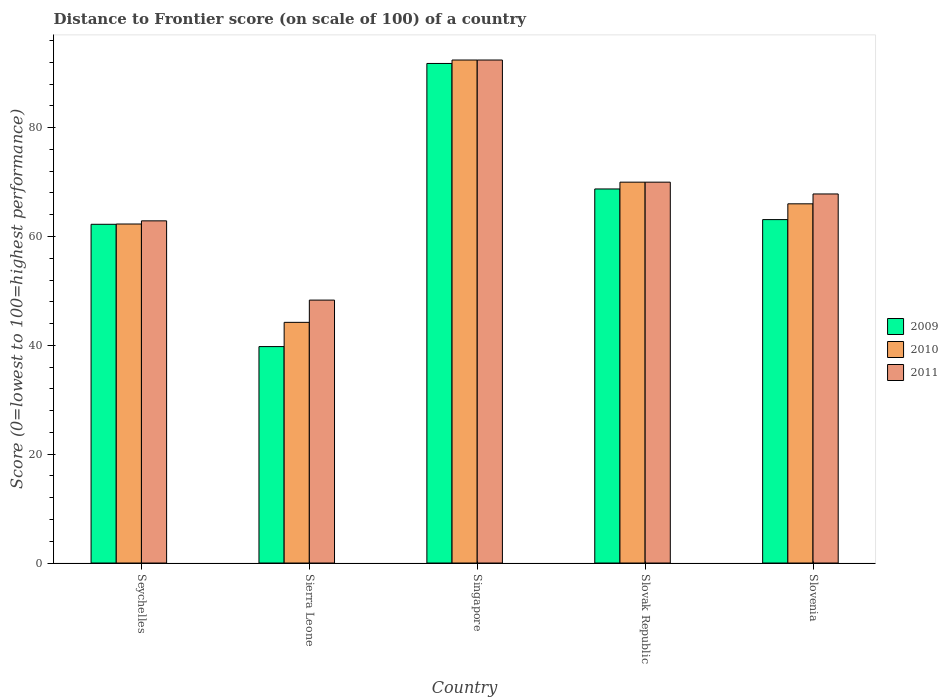How many different coloured bars are there?
Provide a succinct answer. 3. Are the number of bars on each tick of the X-axis equal?
Make the answer very short. Yes. How many bars are there on the 2nd tick from the left?
Ensure brevity in your answer.  3. How many bars are there on the 1st tick from the right?
Give a very brief answer. 3. What is the label of the 1st group of bars from the left?
Ensure brevity in your answer.  Seychelles. In how many cases, is the number of bars for a given country not equal to the number of legend labels?
Provide a succinct answer. 0. What is the distance to frontier score of in 2011 in Slovenia?
Keep it short and to the point. 67.81. Across all countries, what is the maximum distance to frontier score of in 2011?
Provide a succinct answer. 92.42. Across all countries, what is the minimum distance to frontier score of in 2011?
Make the answer very short. 48.31. In which country was the distance to frontier score of in 2009 maximum?
Offer a terse response. Singapore. In which country was the distance to frontier score of in 2009 minimum?
Give a very brief answer. Sierra Leone. What is the total distance to frontier score of in 2011 in the graph?
Provide a succinct answer. 341.39. What is the difference between the distance to frontier score of in 2009 in Sierra Leone and that in Slovenia?
Provide a short and direct response. -23.33. What is the difference between the distance to frontier score of in 2010 in Singapore and the distance to frontier score of in 2011 in Seychelles?
Make the answer very short. 29.55. What is the average distance to frontier score of in 2009 per country?
Your answer should be compact. 65.13. What is the difference between the distance to frontier score of of/in 2009 and distance to frontier score of of/in 2011 in Slovenia?
Your answer should be very brief. -4.71. In how many countries, is the distance to frontier score of in 2010 greater than 8?
Offer a very short reply. 5. What is the ratio of the distance to frontier score of in 2010 in Sierra Leone to that in Slovenia?
Your answer should be very brief. 0.67. Is the distance to frontier score of in 2009 in Singapore less than that in Slovenia?
Offer a terse response. No. What is the difference between the highest and the second highest distance to frontier score of in 2011?
Your response must be concise. -24.61. What is the difference between the highest and the lowest distance to frontier score of in 2011?
Give a very brief answer. 44.11. In how many countries, is the distance to frontier score of in 2009 greater than the average distance to frontier score of in 2009 taken over all countries?
Ensure brevity in your answer.  2. What does the 1st bar from the right in Sierra Leone represents?
Provide a succinct answer. 2011. Are all the bars in the graph horizontal?
Your answer should be compact. No. How many countries are there in the graph?
Ensure brevity in your answer.  5. Are the values on the major ticks of Y-axis written in scientific E-notation?
Your response must be concise. No. Does the graph contain any zero values?
Give a very brief answer. No. Where does the legend appear in the graph?
Your answer should be compact. Center right. What is the title of the graph?
Keep it short and to the point. Distance to Frontier score (on scale of 100) of a country. What is the label or title of the X-axis?
Offer a very short reply. Country. What is the label or title of the Y-axis?
Provide a short and direct response. Score (0=lowest to 100=highest performance). What is the Score (0=lowest to 100=highest performance) in 2009 in Seychelles?
Offer a terse response. 62.24. What is the Score (0=lowest to 100=highest performance) of 2010 in Seychelles?
Your response must be concise. 62.29. What is the Score (0=lowest to 100=highest performance) of 2011 in Seychelles?
Your answer should be compact. 62.87. What is the Score (0=lowest to 100=highest performance) in 2009 in Sierra Leone?
Offer a terse response. 39.77. What is the Score (0=lowest to 100=highest performance) of 2010 in Sierra Leone?
Ensure brevity in your answer.  44.22. What is the Score (0=lowest to 100=highest performance) of 2011 in Sierra Leone?
Your response must be concise. 48.31. What is the Score (0=lowest to 100=highest performance) in 2009 in Singapore?
Offer a terse response. 91.79. What is the Score (0=lowest to 100=highest performance) in 2010 in Singapore?
Offer a very short reply. 92.42. What is the Score (0=lowest to 100=highest performance) in 2011 in Singapore?
Offer a very short reply. 92.42. What is the Score (0=lowest to 100=highest performance) of 2009 in Slovak Republic?
Your answer should be very brief. 68.73. What is the Score (0=lowest to 100=highest performance) in 2010 in Slovak Republic?
Provide a short and direct response. 69.98. What is the Score (0=lowest to 100=highest performance) in 2011 in Slovak Republic?
Your answer should be compact. 69.98. What is the Score (0=lowest to 100=highest performance) in 2009 in Slovenia?
Give a very brief answer. 63.1. What is the Score (0=lowest to 100=highest performance) in 2010 in Slovenia?
Provide a short and direct response. 66. What is the Score (0=lowest to 100=highest performance) of 2011 in Slovenia?
Your response must be concise. 67.81. Across all countries, what is the maximum Score (0=lowest to 100=highest performance) in 2009?
Offer a very short reply. 91.79. Across all countries, what is the maximum Score (0=lowest to 100=highest performance) of 2010?
Provide a short and direct response. 92.42. Across all countries, what is the maximum Score (0=lowest to 100=highest performance) of 2011?
Keep it short and to the point. 92.42. Across all countries, what is the minimum Score (0=lowest to 100=highest performance) in 2009?
Your answer should be compact. 39.77. Across all countries, what is the minimum Score (0=lowest to 100=highest performance) of 2010?
Offer a very short reply. 44.22. Across all countries, what is the minimum Score (0=lowest to 100=highest performance) in 2011?
Your answer should be compact. 48.31. What is the total Score (0=lowest to 100=highest performance) in 2009 in the graph?
Your response must be concise. 325.63. What is the total Score (0=lowest to 100=highest performance) of 2010 in the graph?
Give a very brief answer. 334.91. What is the total Score (0=lowest to 100=highest performance) of 2011 in the graph?
Keep it short and to the point. 341.39. What is the difference between the Score (0=lowest to 100=highest performance) in 2009 in Seychelles and that in Sierra Leone?
Your answer should be very brief. 22.47. What is the difference between the Score (0=lowest to 100=highest performance) of 2010 in Seychelles and that in Sierra Leone?
Provide a succinct answer. 18.07. What is the difference between the Score (0=lowest to 100=highest performance) of 2011 in Seychelles and that in Sierra Leone?
Ensure brevity in your answer.  14.56. What is the difference between the Score (0=lowest to 100=highest performance) of 2009 in Seychelles and that in Singapore?
Keep it short and to the point. -29.55. What is the difference between the Score (0=lowest to 100=highest performance) in 2010 in Seychelles and that in Singapore?
Your answer should be compact. -30.13. What is the difference between the Score (0=lowest to 100=highest performance) in 2011 in Seychelles and that in Singapore?
Your answer should be compact. -29.55. What is the difference between the Score (0=lowest to 100=highest performance) of 2009 in Seychelles and that in Slovak Republic?
Offer a very short reply. -6.49. What is the difference between the Score (0=lowest to 100=highest performance) of 2010 in Seychelles and that in Slovak Republic?
Offer a terse response. -7.69. What is the difference between the Score (0=lowest to 100=highest performance) of 2011 in Seychelles and that in Slovak Republic?
Give a very brief answer. -7.11. What is the difference between the Score (0=lowest to 100=highest performance) in 2009 in Seychelles and that in Slovenia?
Your answer should be compact. -0.86. What is the difference between the Score (0=lowest to 100=highest performance) in 2010 in Seychelles and that in Slovenia?
Give a very brief answer. -3.71. What is the difference between the Score (0=lowest to 100=highest performance) of 2011 in Seychelles and that in Slovenia?
Provide a succinct answer. -4.94. What is the difference between the Score (0=lowest to 100=highest performance) in 2009 in Sierra Leone and that in Singapore?
Offer a terse response. -52.02. What is the difference between the Score (0=lowest to 100=highest performance) of 2010 in Sierra Leone and that in Singapore?
Offer a terse response. -48.2. What is the difference between the Score (0=lowest to 100=highest performance) in 2011 in Sierra Leone and that in Singapore?
Offer a very short reply. -44.11. What is the difference between the Score (0=lowest to 100=highest performance) of 2009 in Sierra Leone and that in Slovak Republic?
Your response must be concise. -28.96. What is the difference between the Score (0=lowest to 100=highest performance) of 2010 in Sierra Leone and that in Slovak Republic?
Provide a succinct answer. -25.76. What is the difference between the Score (0=lowest to 100=highest performance) of 2011 in Sierra Leone and that in Slovak Republic?
Give a very brief answer. -21.67. What is the difference between the Score (0=lowest to 100=highest performance) in 2009 in Sierra Leone and that in Slovenia?
Provide a succinct answer. -23.33. What is the difference between the Score (0=lowest to 100=highest performance) of 2010 in Sierra Leone and that in Slovenia?
Offer a terse response. -21.78. What is the difference between the Score (0=lowest to 100=highest performance) of 2011 in Sierra Leone and that in Slovenia?
Make the answer very short. -19.5. What is the difference between the Score (0=lowest to 100=highest performance) of 2009 in Singapore and that in Slovak Republic?
Provide a succinct answer. 23.06. What is the difference between the Score (0=lowest to 100=highest performance) in 2010 in Singapore and that in Slovak Republic?
Provide a short and direct response. 22.44. What is the difference between the Score (0=lowest to 100=highest performance) in 2011 in Singapore and that in Slovak Republic?
Your answer should be very brief. 22.44. What is the difference between the Score (0=lowest to 100=highest performance) of 2009 in Singapore and that in Slovenia?
Make the answer very short. 28.69. What is the difference between the Score (0=lowest to 100=highest performance) of 2010 in Singapore and that in Slovenia?
Your answer should be very brief. 26.42. What is the difference between the Score (0=lowest to 100=highest performance) of 2011 in Singapore and that in Slovenia?
Keep it short and to the point. 24.61. What is the difference between the Score (0=lowest to 100=highest performance) in 2009 in Slovak Republic and that in Slovenia?
Your answer should be very brief. 5.63. What is the difference between the Score (0=lowest to 100=highest performance) of 2010 in Slovak Republic and that in Slovenia?
Your response must be concise. 3.98. What is the difference between the Score (0=lowest to 100=highest performance) in 2011 in Slovak Republic and that in Slovenia?
Give a very brief answer. 2.17. What is the difference between the Score (0=lowest to 100=highest performance) of 2009 in Seychelles and the Score (0=lowest to 100=highest performance) of 2010 in Sierra Leone?
Offer a very short reply. 18.02. What is the difference between the Score (0=lowest to 100=highest performance) of 2009 in Seychelles and the Score (0=lowest to 100=highest performance) of 2011 in Sierra Leone?
Provide a short and direct response. 13.93. What is the difference between the Score (0=lowest to 100=highest performance) of 2010 in Seychelles and the Score (0=lowest to 100=highest performance) of 2011 in Sierra Leone?
Ensure brevity in your answer.  13.98. What is the difference between the Score (0=lowest to 100=highest performance) in 2009 in Seychelles and the Score (0=lowest to 100=highest performance) in 2010 in Singapore?
Offer a terse response. -30.18. What is the difference between the Score (0=lowest to 100=highest performance) in 2009 in Seychelles and the Score (0=lowest to 100=highest performance) in 2011 in Singapore?
Your answer should be very brief. -30.18. What is the difference between the Score (0=lowest to 100=highest performance) of 2010 in Seychelles and the Score (0=lowest to 100=highest performance) of 2011 in Singapore?
Give a very brief answer. -30.13. What is the difference between the Score (0=lowest to 100=highest performance) in 2009 in Seychelles and the Score (0=lowest to 100=highest performance) in 2010 in Slovak Republic?
Your response must be concise. -7.74. What is the difference between the Score (0=lowest to 100=highest performance) of 2009 in Seychelles and the Score (0=lowest to 100=highest performance) of 2011 in Slovak Republic?
Your response must be concise. -7.74. What is the difference between the Score (0=lowest to 100=highest performance) of 2010 in Seychelles and the Score (0=lowest to 100=highest performance) of 2011 in Slovak Republic?
Give a very brief answer. -7.69. What is the difference between the Score (0=lowest to 100=highest performance) in 2009 in Seychelles and the Score (0=lowest to 100=highest performance) in 2010 in Slovenia?
Keep it short and to the point. -3.76. What is the difference between the Score (0=lowest to 100=highest performance) of 2009 in Seychelles and the Score (0=lowest to 100=highest performance) of 2011 in Slovenia?
Offer a very short reply. -5.57. What is the difference between the Score (0=lowest to 100=highest performance) in 2010 in Seychelles and the Score (0=lowest to 100=highest performance) in 2011 in Slovenia?
Provide a succinct answer. -5.52. What is the difference between the Score (0=lowest to 100=highest performance) in 2009 in Sierra Leone and the Score (0=lowest to 100=highest performance) in 2010 in Singapore?
Provide a succinct answer. -52.65. What is the difference between the Score (0=lowest to 100=highest performance) in 2009 in Sierra Leone and the Score (0=lowest to 100=highest performance) in 2011 in Singapore?
Your answer should be compact. -52.65. What is the difference between the Score (0=lowest to 100=highest performance) in 2010 in Sierra Leone and the Score (0=lowest to 100=highest performance) in 2011 in Singapore?
Offer a very short reply. -48.2. What is the difference between the Score (0=lowest to 100=highest performance) in 2009 in Sierra Leone and the Score (0=lowest to 100=highest performance) in 2010 in Slovak Republic?
Your answer should be very brief. -30.21. What is the difference between the Score (0=lowest to 100=highest performance) in 2009 in Sierra Leone and the Score (0=lowest to 100=highest performance) in 2011 in Slovak Republic?
Keep it short and to the point. -30.21. What is the difference between the Score (0=lowest to 100=highest performance) in 2010 in Sierra Leone and the Score (0=lowest to 100=highest performance) in 2011 in Slovak Republic?
Offer a terse response. -25.76. What is the difference between the Score (0=lowest to 100=highest performance) of 2009 in Sierra Leone and the Score (0=lowest to 100=highest performance) of 2010 in Slovenia?
Make the answer very short. -26.23. What is the difference between the Score (0=lowest to 100=highest performance) of 2009 in Sierra Leone and the Score (0=lowest to 100=highest performance) of 2011 in Slovenia?
Keep it short and to the point. -28.04. What is the difference between the Score (0=lowest to 100=highest performance) in 2010 in Sierra Leone and the Score (0=lowest to 100=highest performance) in 2011 in Slovenia?
Ensure brevity in your answer.  -23.59. What is the difference between the Score (0=lowest to 100=highest performance) of 2009 in Singapore and the Score (0=lowest to 100=highest performance) of 2010 in Slovak Republic?
Keep it short and to the point. 21.81. What is the difference between the Score (0=lowest to 100=highest performance) of 2009 in Singapore and the Score (0=lowest to 100=highest performance) of 2011 in Slovak Republic?
Ensure brevity in your answer.  21.81. What is the difference between the Score (0=lowest to 100=highest performance) in 2010 in Singapore and the Score (0=lowest to 100=highest performance) in 2011 in Slovak Republic?
Give a very brief answer. 22.44. What is the difference between the Score (0=lowest to 100=highest performance) of 2009 in Singapore and the Score (0=lowest to 100=highest performance) of 2010 in Slovenia?
Provide a short and direct response. 25.79. What is the difference between the Score (0=lowest to 100=highest performance) in 2009 in Singapore and the Score (0=lowest to 100=highest performance) in 2011 in Slovenia?
Make the answer very short. 23.98. What is the difference between the Score (0=lowest to 100=highest performance) in 2010 in Singapore and the Score (0=lowest to 100=highest performance) in 2011 in Slovenia?
Offer a very short reply. 24.61. What is the difference between the Score (0=lowest to 100=highest performance) in 2009 in Slovak Republic and the Score (0=lowest to 100=highest performance) in 2010 in Slovenia?
Provide a short and direct response. 2.73. What is the difference between the Score (0=lowest to 100=highest performance) in 2010 in Slovak Republic and the Score (0=lowest to 100=highest performance) in 2011 in Slovenia?
Offer a very short reply. 2.17. What is the average Score (0=lowest to 100=highest performance) in 2009 per country?
Provide a succinct answer. 65.13. What is the average Score (0=lowest to 100=highest performance) in 2010 per country?
Make the answer very short. 66.98. What is the average Score (0=lowest to 100=highest performance) in 2011 per country?
Offer a terse response. 68.28. What is the difference between the Score (0=lowest to 100=highest performance) in 2009 and Score (0=lowest to 100=highest performance) in 2010 in Seychelles?
Give a very brief answer. -0.05. What is the difference between the Score (0=lowest to 100=highest performance) of 2009 and Score (0=lowest to 100=highest performance) of 2011 in Seychelles?
Provide a short and direct response. -0.63. What is the difference between the Score (0=lowest to 100=highest performance) of 2010 and Score (0=lowest to 100=highest performance) of 2011 in Seychelles?
Make the answer very short. -0.58. What is the difference between the Score (0=lowest to 100=highest performance) in 2009 and Score (0=lowest to 100=highest performance) in 2010 in Sierra Leone?
Ensure brevity in your answer.  -4.45. What is the difference between the Score (0=lowest to 100=highest performance) in 2009 and Score (0=lowest to 100=highest performance) in 2011 in Sierra Leone?
Offer a very short reply. -8.54. What is the difference between the Score (0=lowest to 100=highest performance) of 2010 and Score (0=lowest to 100=highest performance) of 2011 in Sierra Leone?
Your answer should be very brief. -4.09. What is the difference between the Score (0=lowest to 100=highest performance) in 2009 and Score (0=lowest to 100=highest performance) in 2010 in Singapore?
Your answer should be compact. -0.63. What is the difference between the Score (0=lowest to 100=highest performance) of 2009 and Score (0=lowest to 100=highest performance) of 2011 in Singapore?
Your answer should be compact. -0.63. What is the difference between the Score (0=lowest to 100=highest performance) of 2010 and Score (0=lowest to 100=highest performance) of 2011 in Singapore?
Give a very brief answer. 0. What is the difference between the Score (0=lowest to 100=highest performance) in 2009 and Score (0=lowest to 100=highest performance) in 2010 in Slovak Republic?
Provide a short and direct response. -1.25. What is the difference between the Score (0=lowest to 100=highest performance) in 2009 and Score (0=lowest to 100=highest performance) in 2011 in Slovak Republic?
Your answer should be compact. -1.25. What is the difference between the Score (0=lowest to 100=highest performance) in 2009 and Score (0=lowest to 100=highest performance) in 2011 in Slovenia?
Your answer should be compact. -4.71. What is the difference between the Score (0=lowest to 100=highest performance) in 2010 and Score (0=lowest to 100=highest performance) in 2011 in Slovenia?
Your answer should be compact. -1.81. What is the ratio of the Score (0=lowest to 100=highest performance) of 2009 in Seychelles to that in Sierra Leone?
Provide a short and direct response. 1.56. What is the ratio of the Score (0=lowest to 100=highest performance) in 2010 in Seychelles to that in Sierra Leone?
Your response must be concise. 1.41. What is the ratio of the Score (0=lowest to 100=highest performance) in 2011 in Seychelles to that in Sierra Leone?
Your response must be concise. 1.3. What is the ratio of the Score (0=lowest to 100=highest performance) of 2009 in Seychelles to that in Singapore?
Make the answer very short. 0.68. What is the ratio of the Score (0=lowest to 100=highest performance) in 2010 in Seychelles to that in Singapore?
Offer a very short reply. 0.67. What is the ratio of the Score (0=lowest to 100=highest performance) of 2011 in Seychelles to that in Singapore?
Make the answer very short. 0.68. What is the ratio of the Score (0=lowest to 100=highest performance) of 2009 in Seychelles to that in Slovak Republic?
Make the answer very short. 0.91. What is the ratio of the Score (0=lowest to 100=highest performance) in 2010 in Seychelles to that in Slovak Republic?
Ensure brevity in your answer.  0.89. What is the ratio of the Score (0=lowest to 100=highest performance) in 2011 in Seychelles to that in Slovak Republic?
Provide a short and direct response. 0.9. What is the ratio of the Score (0=lowest to 100=highest performance) of 2009 in Seychelles to that in Slovenia?
Provide a succinct answer. 0.99. What is the ratio of the Score (0=lowest to 100=highest performance) in 2010 in Seychelles to that in Slovenia?
Keep it short and to the point. 0.94. What is the ratio of the Score (0=lowest to 100=highest performance) in 2011 in Seychelles to that in Slovenia?
Offer a very short reply. 0.93. What is the ratio of the Score (0=lowest to 100=highest performance) of 2009 in Sierra Leone to that in Singapore?
Provide a short and direct response. 0.43. What is the ratio of the Score (0=lowest to 100=highest performance) in 2010 in Sierra Leone to that in Singapore?
Your answer should be very brief. 0.48. What is the ratio of the Score (0=lowest to 100=highest performance) in 2011 in Sierra Leone to that in Singapore?
Give a very brief answer. 0.52. What is the ratio of the Score (0=lowest to 100=highest performance) in 2009 in Sierra Leone to that in Slovak Republic?
Offer a very short reply. 0.58. What is the ratio of the Score (0=lowest to 100=highest performance) in 2010 in Sierra Leone to that in Slovak Republic?
Ensure brevity in your answer.  0.63. What is the ratio of the Score (0=lowest to 100=highest performance) in 2011 in Sierra Leone to that in Slovak Republic?
Your answer should be compact. 0.69. What is the ratio of the Score (0=lowest to 100=highest performance) of 2009 in Sierra Leone to that in Slovenia?
Keep it short and to the point. 0.63. What is the ratio of the Score (0=lowest to 100=highest performance) in 2010 in Sierra Leone to that in Slovenia?
Offer a terse response. 0.67. What is the ratio of the Score (0=lowest to 100=highest performance) of 2011 in Sierra Leone to that in Slovenia?
Your answer should be compact. 0.71. What is the ratio of the Score (0=lowest to 100=highest performance) in 2009 in Singapore to that in Slovak Republic?
Your answer should be compact. 1.34. What is the ratio of the Score (0=lowest to 100=highest performance) in 2010 in Singapore to that in Slovak Republic?
Your answer should be compact. 1.32. What is the ratio of the Score (0=lowest to 100=highest performance) in 2011 in Singapore to that in Slovak Republic?
Keep it short and to the point. 1.32. What is the ratio of the Score (0=lowest to 100=highest performance) in 2009 in Singapore to that in Slovenia?
Keep it short and to the point. 1.45. What is the ratio of the Score (0=lowest to 100=highest performance) in 2010 in Singapore to that in Slovenia?
Provide a succinct answer. 1.4. What is the ratio of the Score (0=lowest to 100=highest performance) in 2011 in Singapore to that in Slovenia?
Make the answer very short. 1.36. What is the ratio of the Score (0=lowest to 100=highest performance) in 2009 in Slovak Republic to that in Slovenia?
Give a very brief answer. 1.09. What is the ratio of the Score (0=lowest to 100=highest performance) of 2010 in Slovak Republic to that in Slovenia?
Your response must be concise. 1.06. What is the ratio of the Score (0=lowest to 100=highest performance) of 2011 in Slovak Republic to that in Slovenia?
Your answer should be very brief. 1.03. What is the difference between the highest and the second highest Score (0=lowest to 100=highest performance) of 2009?
Offer a very short reply. 23.06. What is the difference between the highest and the second highest Score (0=lowest to 100=highest performance) of 2010?
Provide a short and direct response. 22.44. What is the difference between the highest and the second highest Score (0=lowest to 100=highest performance) in 2011?
Provide a short and direct response. 22.44. What is the difference between the highest and the lowest Score (0=lowest to 100=highest performance) in 2009?
Give a very brief answer. 52.02. What is the difference between the highest and the lowest Score (0=lowest to 100=highest performance) of 2010?
Make the answer very short. 48.2. What is the difference between the highest and the lowest Score (0=lowest to 100=highest performance) in 2011?
Ensure brevity in your answer.  44.11. 